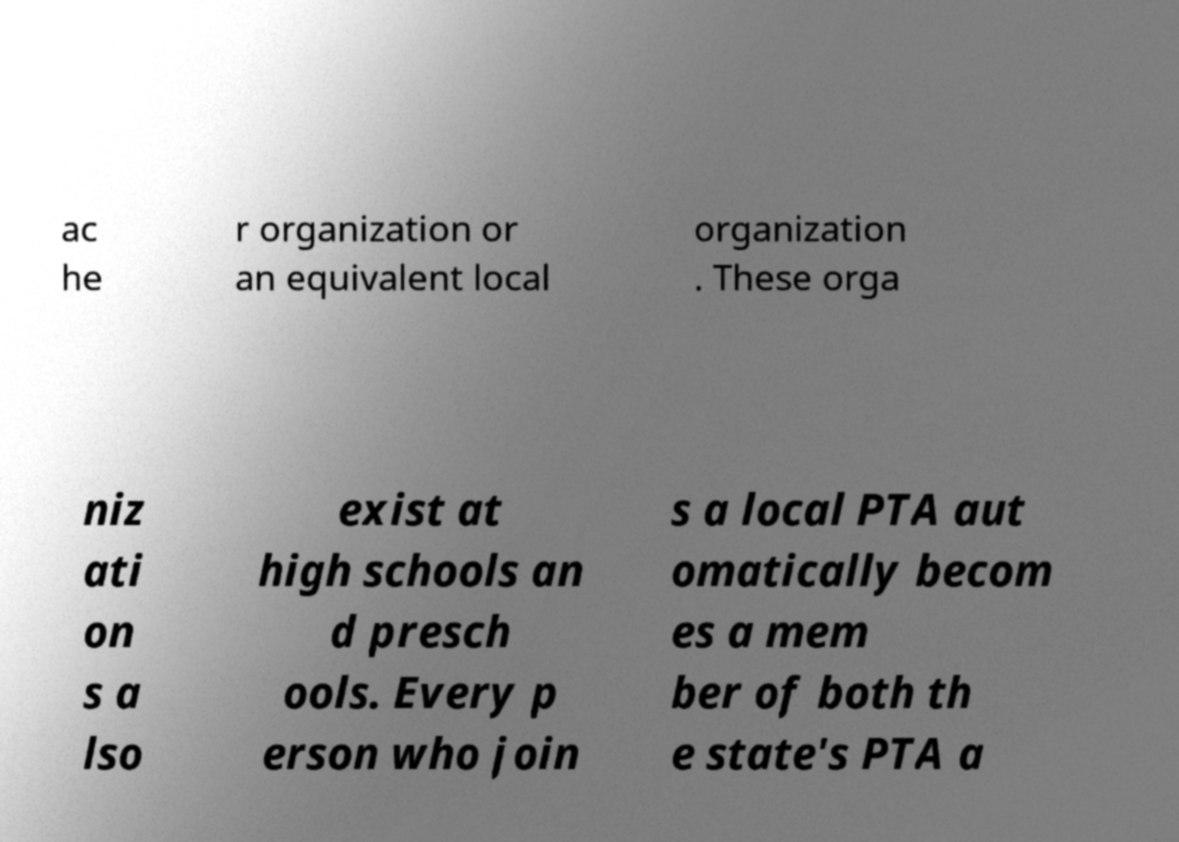I need the written content from this picture converted into text. Can you do that? ac he r organization or an equivalent local organization . These orga niz ati on s a lso exist at high schools an d presch ools. Every p erson who join s a local PTA aut omatically becom es a mem ber of both th e state's PTA a 